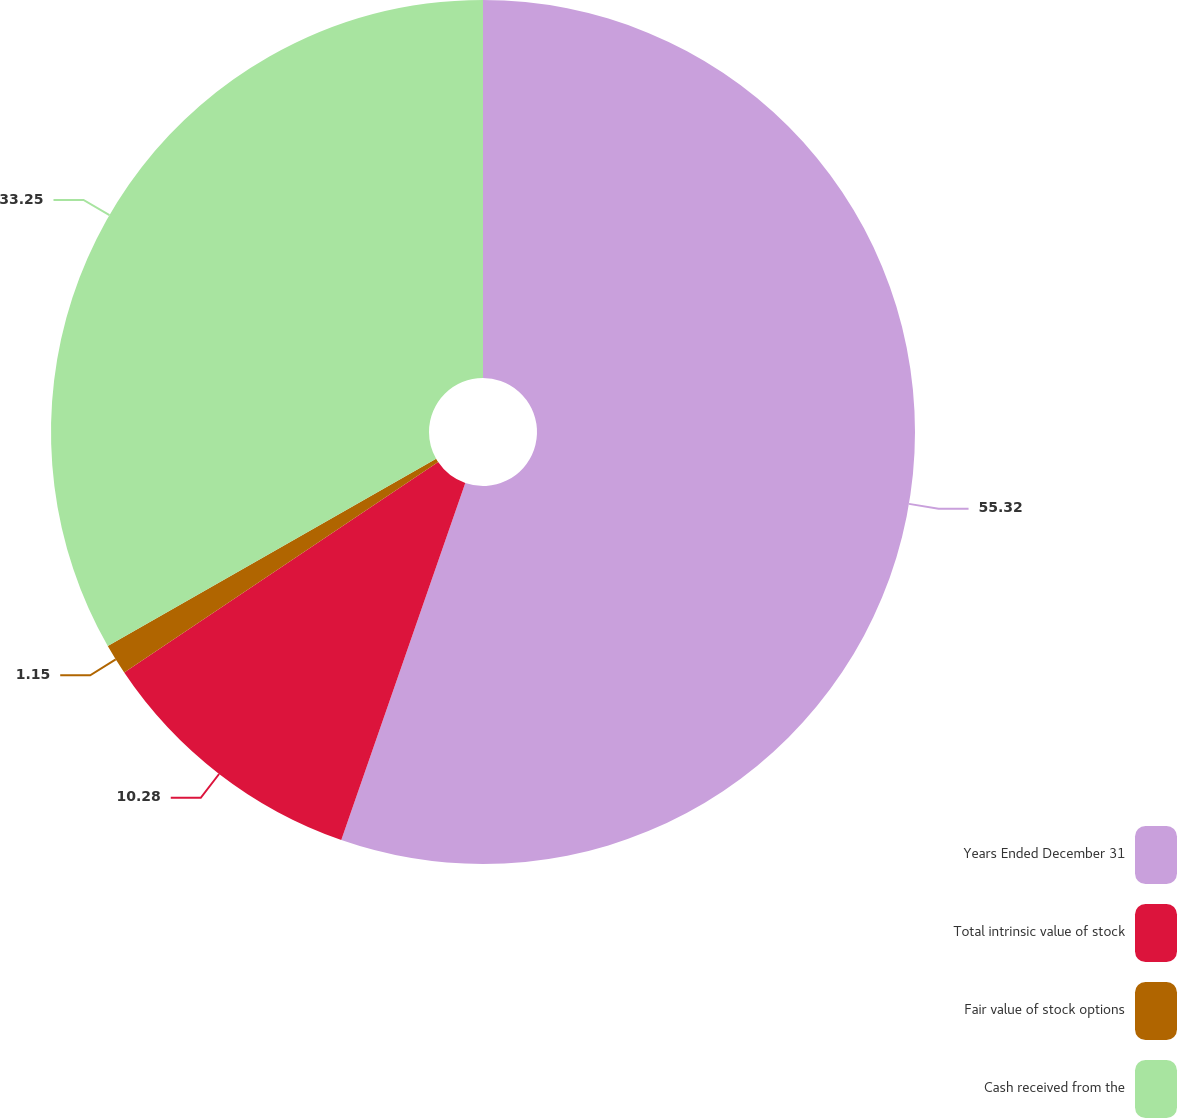<chart> <loc_0><loc_0><loc_500><loc_500><pie_chart><fcel>Years Ended December 31<fcel>Total intrinsic value of stock<fcel>Fair value of stock options<fcel>Cash received from the<nl><fcel>55.32%<fcel>10.28%<fcel>1.15%<fcel>33.25%<nl></chart> 